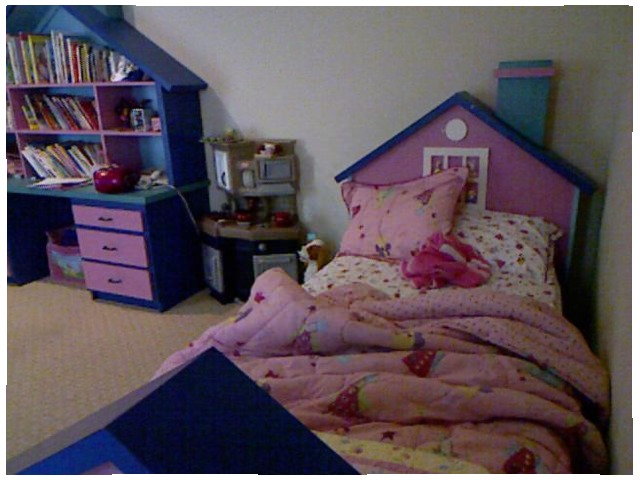<image>
Is the drawer behind the bed? No. The drawer is not behind the bed. From this viewpoint, the drawer appears to be positioned elsewhere in the scene. 